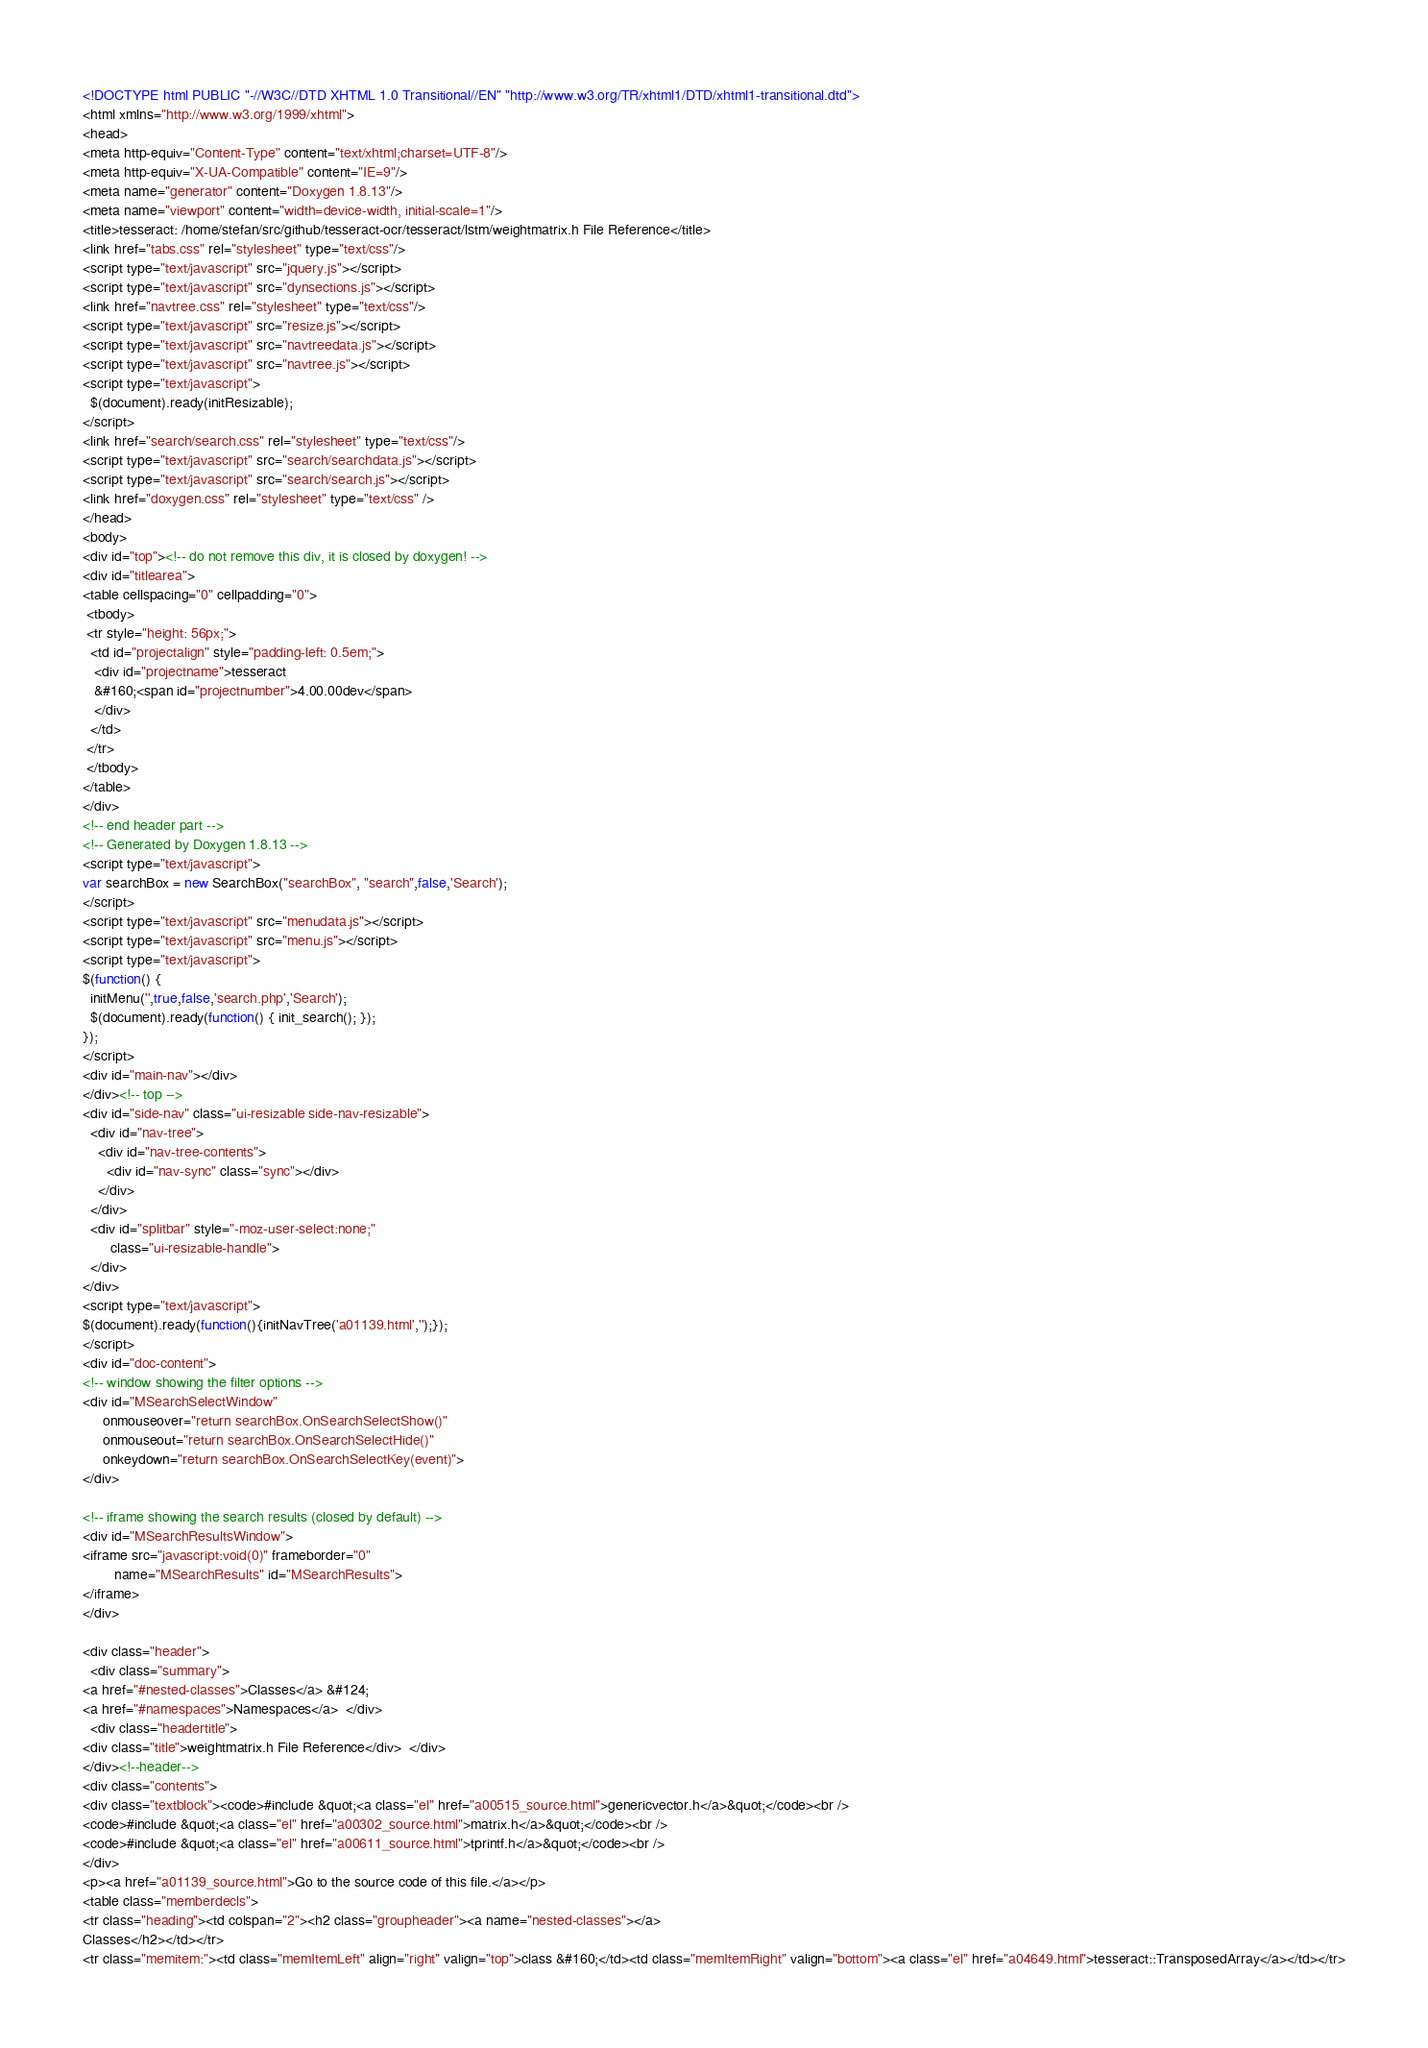Convert code to text. <code><loc_0><loc_0><loc_500><loc_500><_HTML_><!DOCTYPE html PUBLIC "-//W3C//DTD XHTML 1.0 Transitional//EN" "http://www.w3.org/TR/xhtml1/DTD/xhtml1-transitional.dtd">
<html xmlns="http://www.w3.org/1999/xhtml">
<head>
<meta http-equiv="Content-Type" content="text/xhtml;charset=UTF-8"/>
<meta http-equiv="X-UA-Compatible" content="IE=9"/>
<meta name="generator" content="Doxygen 1.8.13"/>
<meta name="viewport" content="width=device-width, initial-scale=1"/>
<title>tesseract: /home/stefan/src/github/tesseract-ocr/tesseract/lstm/weightmatrix.h File Reference</title>
<link href="tabs.css" rel="stylesheet" type="text/css"/>
<script type="text/javascript" src="jquery.js"></script>
<script type="text/javascript" src="dynsections.js"></script>
<link href="navtree.css" rel="stylesheet" type="text/css"/>
<script type="text/javascript" src="resize.js"></script>
<script type="text/javascript" src="navtreedata.js"></script>
<script type="text/javascript" src="navtree.js"></script>
<script type="text/javascript">
  $(document).ready(initResizable);
</script>
<link href="search/search.css" rel="stylesheet" type="text/css"/>
<script type="text/javascript" src="search/searchdata.js"></script>
<script type="text/javascript" src="search/search.js"></script>
<link href="doxygen.css" rel="stylesheet" type="text/css" />
</head>
<body>
<div id="top"><!-- do not remove this div, it is closed by doxygen! -->
<div id="titlearea">
<table cellspacing="0" cellpadding="0">
 <tbody>
 <tr style="height: 56px;">
  <td id="projectalign" style="padding-left: 0.5em;">
   <div id="projectname">tesseract
   &#160;<span id="projectnumber">4.00.00dev</span>
   </div>
  </td>
 </tr>
 </tbody>
</table>
</div>
<!-- end header part -->
<!-- Generated by Doxygen 1.8.13 -->
<script type="text/javascript">
var searchBox = new SearchBox("searchBox", "search",false,'Search');
</script>
<script type="text/javascript" src="menudata.js"></script>
<script type="text/javascript" src="menu.js"></script>
<script type="text/javascript">
$(function() {
  initMenu('',true,false,'search.php','Search');
  $(document).ready(function() { init_search(); });
});
</script>
<div id="main-nav"></div>
</div><!-- top -->
<div id="side-nav" class="ui-resizable side-nav-resizable">
  <div id="nav-tree">
    <div id="nav-tree-contents">
      <div id="nav-sync" class="sync"></div>
    </div>
  </div>
  <div id="splitbar" style="-moz-user-select:none;" 
       class="ui-resizable-handle">
  </div>
</div>
<script type="text/javascript">
$(document).ready(function(){initNavTree('a01139.html','');});
</script>
<div id="doc-content">
<!-- window showing the filter options -->
<div id="MSearchSelectWindow"
     onmouseover="return searchBox.OnSearchSelectShow()"
     onmouseout="return searchBox.OnSearchSelectHide()"
     onkeydown="return searchBox.OnSearchSelectKey(event)">
</div>

<!-- iframe showing the search results (closed by default) -->
<div id="MSearchResultsWindow">
<iframe src="javascript:void(0)" frameborder="0" 
        name="MSearchResults" id="MSearchResults">
</iframe>
</div>

<div class="header">
  <div class="summary">
<a href="#nested-classes">Classes</a> &#124;
<a href="#namespaces">Namespaces</a>  </div>
  <div class="headertitle">
<div class="title">weightmatrix.h File Reference</div>  </div>
</div><!--header-->
<div class="contents">
<div class="textblock"><code>#include &quot;<a class="el" href="a00515_source.html">genericvector.h</a>&quot;</code><br />
<code>#include &quot;<a class="el" href="a00302_source.html">matrix.h</a>&quot;</code><br />
<code>#include &quot;<a class="el" href="a00611_source.html">tprintf.h</a>&quot;</code><br />
</div>
<p><a href="a01139_source.html">Go to the source code of this file.</a></p>
<table class="memberdecls">
<tr class="heading"><td colspan="2"><h2 class="groupheader"><a name="nested-classes"></a>
Classes</h2></td></tr>
<tr class="memitem:"><td class="memItemLeft" align="right" valign="top">class &#160;</td><td class="memItemRight" valign="bottom"><a class="el" href="a04649.html">tesseract::TransposedArray</a></td></tr></code> 